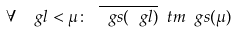Convert formula to latex. <formula><loc_0><loc_0><loc_500><loc_500>\forall \ \ g l < \mu \colon \ \overline { \ g s ( \ g l ) } \ t m \ g s ( \mu )</formula> 